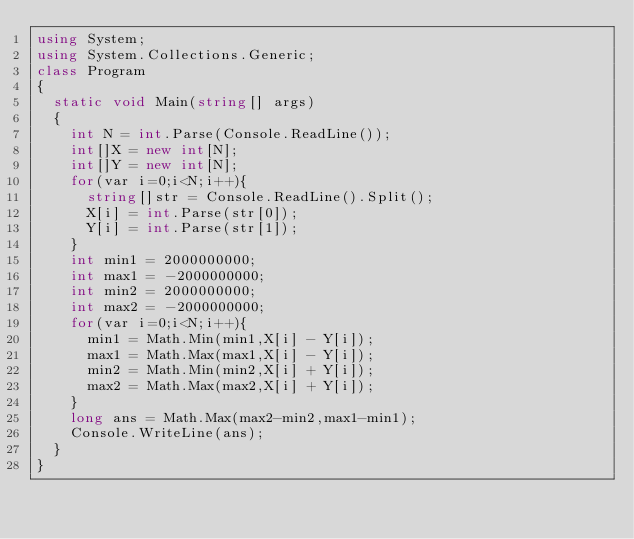Convert code to text. <code><loc_0><loc_0><loc_500><loc_500><_C#_>using System;
using System.Collections.Generic;
class Program
{
	static void Main(string[] args)
	{
		int N = int.Parse(Console.ReadLine());
		int[]X = new int[N];
		int[]Y = new int[N];
		for(var i=0;i<N;i++){
			string[]str = Console.ReadLine().Split();
			X[i] = int.Parse(str[0]);
			Y[i] = int.Parse(str[1]);
		}
		int min1 = 2000000000;
		int max1 = -2000000000;
		int min2 = 2000000000;
		int max2 = -2000000000;
		for(var i=0;i<N;i++){
			min1 = Math.Min(min1,X[i] - Y[i]);
			max1 = Math.Max(max1,X[i] - Y[i]);
			min2 = Math.Min(min2,X[i] + Y[i]);
			max2 = Math.Max(max2,X[i] + Y[i]);
		}
		long ans = Math.Max(max2-min2,max1-min1);
		Console.WriteLine(ans);
	}
}</code> 